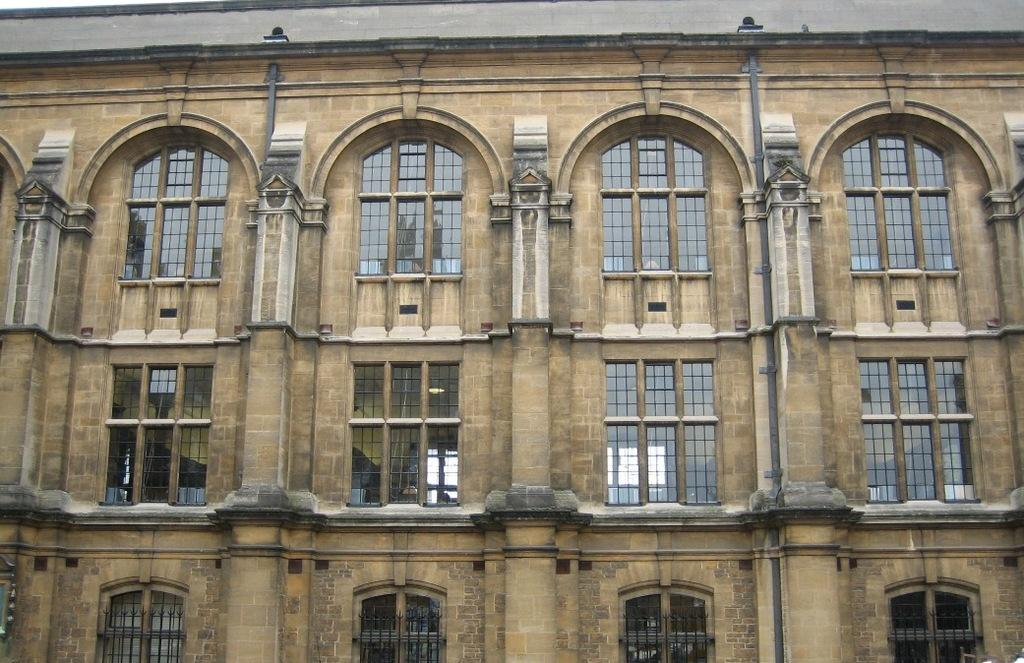What type of structure is present in the image? There is a building in the image. What are some features of the building? The building has windows and glasses. Are there any other elements visible in the image related to the building? Yes, there are pipes visible in the image. What type of butter is being used to hold the building together in the image? There is no butter present in the image, and the building does not require any adhesive to hold it together. 